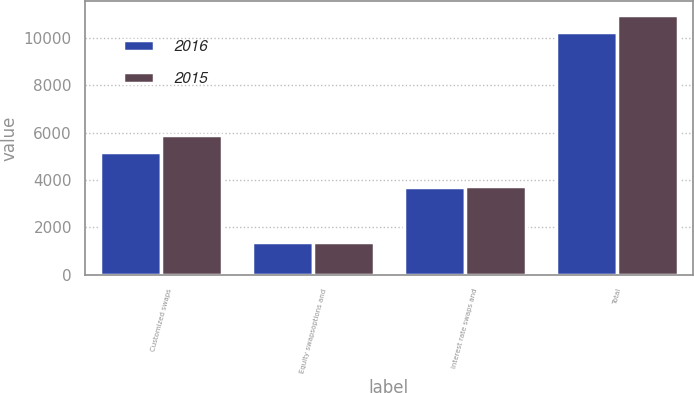Convert chart to OTSL. <chart><loc_0><loc_0><loc_500><loc_500><stacked_bar_chart><ecel><fcel>Customized swaps<fcel>Equity swapsoptions and<fcel>Interest rate swaps and<fcel>Total<nl><fcel>2016<fcel>5191<fcel>1362<fcel>3703<fcel>10256<nl><fcel>2015<fcel>5877<fcel>1362<fcel>3740<fcel>10979<nl></chart> 